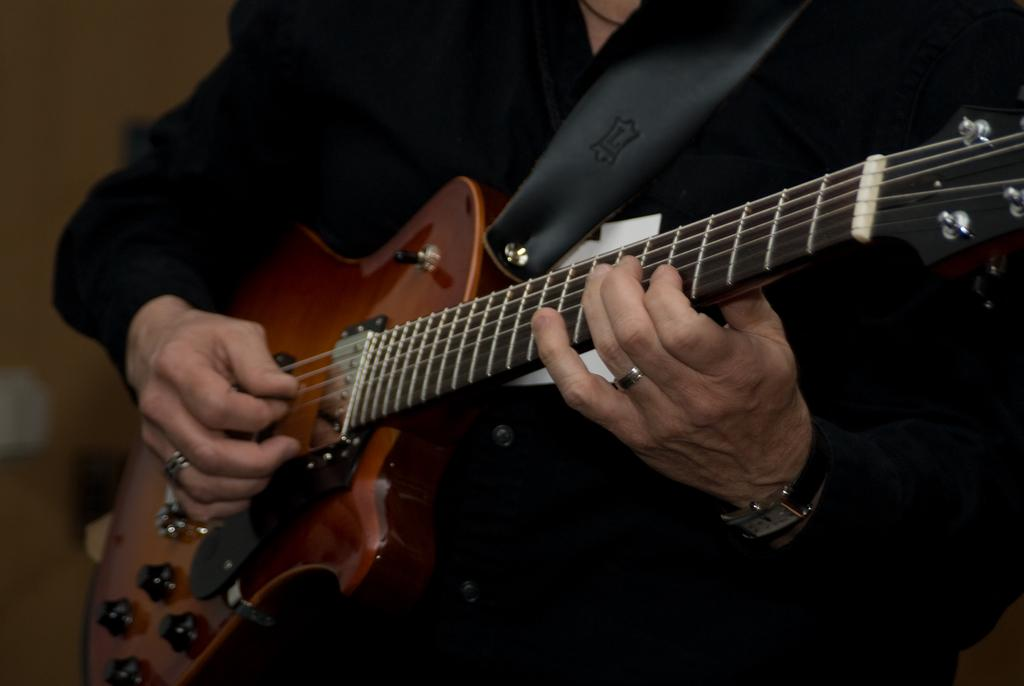What is the main subject of the image? There is a person in the image. What is the person wearing? The person is wearing a black suit. What is the person doing in the image? The person is playing a guitar. Can you describe any accessories the person is wearing? There is a watch on the person's hand. What type of jam is the person spreading on the plate in the image? There is no plate or jam present in the image; the person is playing a guitar while wearing a black suit and a watch. 